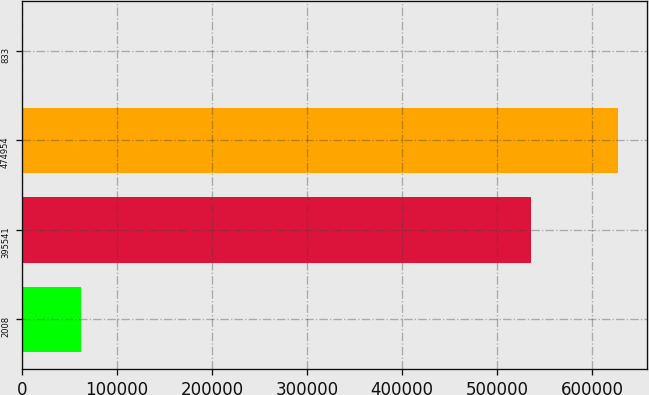Convert chart to OTSL. <chart><loc_0><loc_0><loc_500><loc_500><bar_chart><fcel>2008<fcel>395541<fcel>474954<fcel>833<nl><fcel>62738.8<fcel>535444<fcel>626619<fcel>85.4<nl></chart> 